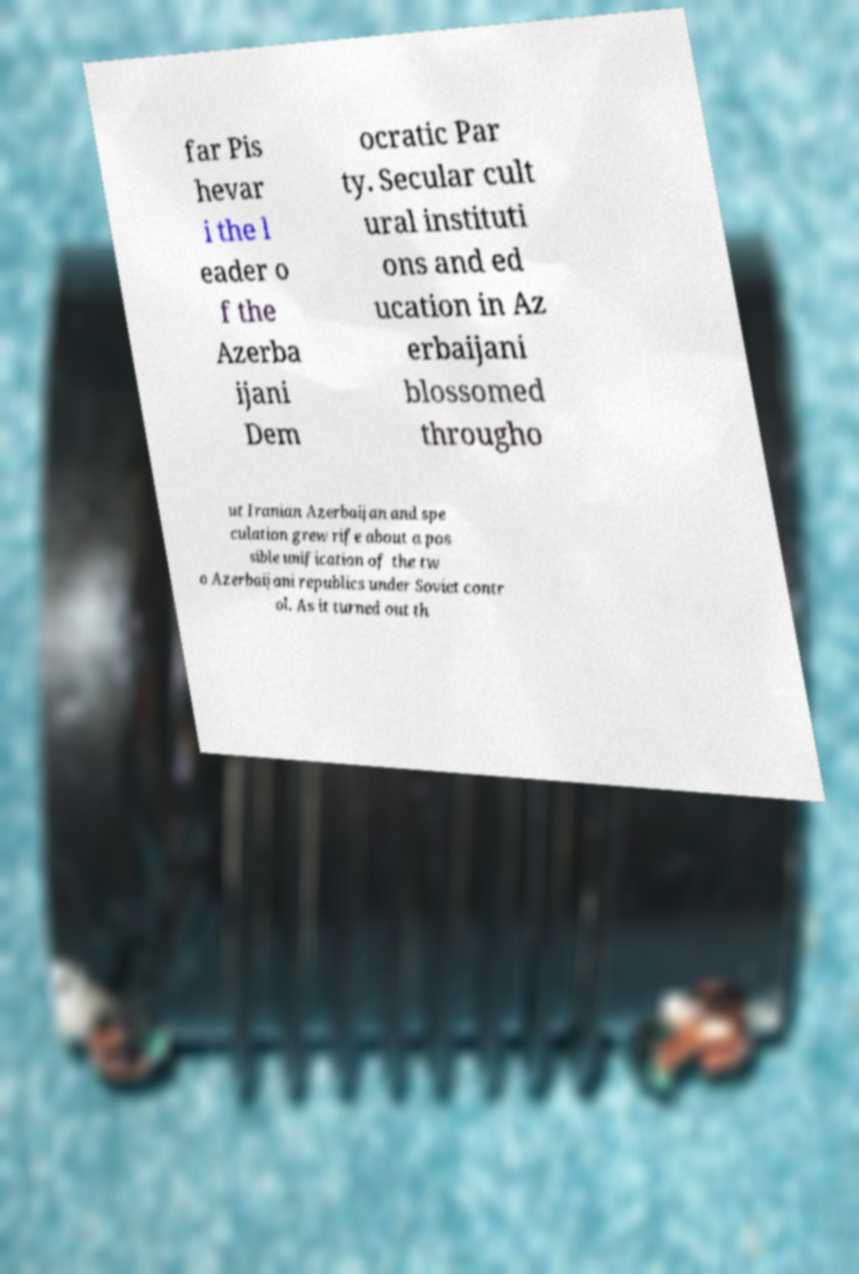Please identify and transcribe the text found in this image. far Pis hevar i the l eader o f the Azerba ijani Dem ocratic Par ty. Secular cult ural instituti ons and ed ucation in Az erbaijani blossomed througho ut Iranian Azerbaijan and spe culation grew rife about a pos sible unification of the tw o Azerbaijani republics under Soviet contr ol. As it turned out th 